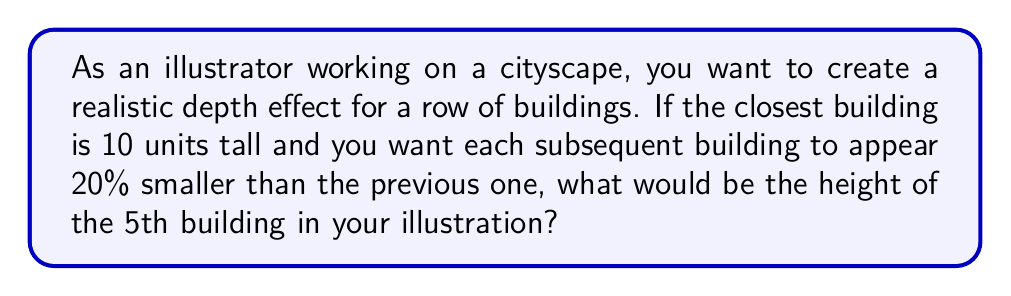Show me your answer to this math problem. Let's approach this step-by-step:

1) Let's define our series:
   $a_1 = 10$ (height of the first building)
   $r = 0.8$ (each building is 80% of the previous one, or 20% smaller)

2) We're looking for the 5th term in this geometric sequence. The formula for the nth term of a geometric sequence is:

   $a_n = a_1 * r^{n-1}$

3) In this case, we're looking for $a_5$, so:

   $a_5 = 10 * (0.8)^{5-1}$

4) Let's calculate:
   $a_5 = 10 * (0.8)^4$
   $a_5 = 10 * 0.4096$
   $a_5 = 4.096$

5) Rounding to two decimal places:
   $a_5 ≈ 4.10$ units

This means the 5th building in your illustration should be approximately 4.10 units tall to create a realistic depth effect.
Answer: 4.10 units 